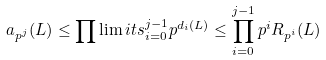Convert formula to latex. <formula><loc_0><loc_0><loc_500><loc_500>a _ { p ^ { j } } ( L ) \leq \prod \lim i t s ^ { j - 1 } _ { i = 0 } p ^ { d _ { i } ( L ) } \leq \prod ^ { j - 1 } _ { i = 0 } p ^ { i } R _ { p ^ { i } } ( L )</formula> 